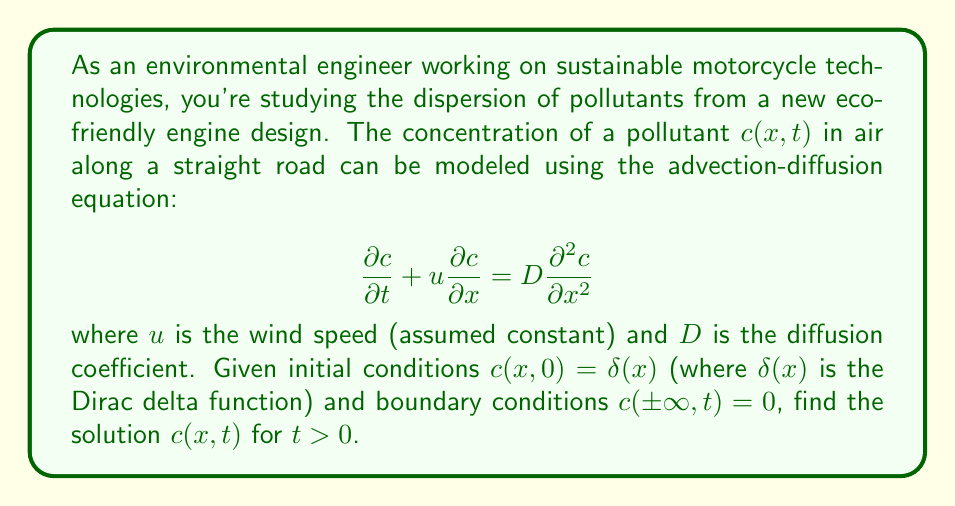Solve this math problem. To solve this partial differential equation (PDE), we'll follow these steps:

1) First, we recognize this as the advection-diffusion equation with a point source initial condition.

2) We can solve this equation using the method of Fourier transforms. Let's define the Fourier transform of $c(x,t)$ as:

   $$\hat{c}(k,t) = \int_{-\infty}^{\infty} c(x,t) e^{-ikx} dx$$

3) Taking the Fourier transform of both sides of the PDE:

   $$\frac{\partial \hat{c}}{\partial t} + iku\hat{c} = -Dk^2\hat{c}$$

4) This is now an ordinary differential equation in $t$:

   $$\frac{\partial \hat{c}}{\partial t} = -(iku + Dk^2)\hat{c}$$

5) The solution to this ODE is:

   $$\hat{c}(k,t) = \hat{c}(k,0) e^{-(iku + Dk^2)t}$$

6) The Fourier transform of the initial condition $\delta(x)$ is 1, so:

   $$\hat{c}(k,t) = e^{-(iku + Dk^2)t}$$

7) To find $c(x,t)$, we need to take the inverse Fourier transform:

   $$c(x,t) = \frac{1}{2\pi} \int_{-\infty}^{\infty} e^{-(iku + Dk^2)t} e^{ikx} dk$$

8) This integral can be evaluated using the method of completing the square:

   $$c(x,t) = \frac{1}{2\pi} \int_{-\infty}^{\infty} e^{-Dk^2t - ikut + ikx} dk$$
   
   $$= \frac{1}{2\pi} \int_{-\infty}^{\infty} e^{-Dt(k^2 + \frac{2ik(ut-x)}{2Dt})} dk$$
   
   $$= \frac{1}{2\pi} e^{-\frac{(x-ut)^2}{4Dt}} \int_{-\infty}^{\infty} e^{-Dt(k + \frac{i(ut-x)}{2Dt})^2} dk$$

9) The integral is now a standard Gaussian integral, which evaluates to $\sqrt{\frac{\pi}{Dt}}$.

10) Therefore, the final solution is:

    $$c(x,t) = \frac{1}{\sqrt{4\pi Dt}} e^{-\frac{(x-ut)^2}{4Dt}}$$

This is the fundamental solution to the advection-diffusion equation, also known as the Green's function.
Answer: $$c(x,t) = \frac{1}{\sqrt{4\pi Dt}} e^{-\frac{(x-ut)^2}{4Dt}}$$ 